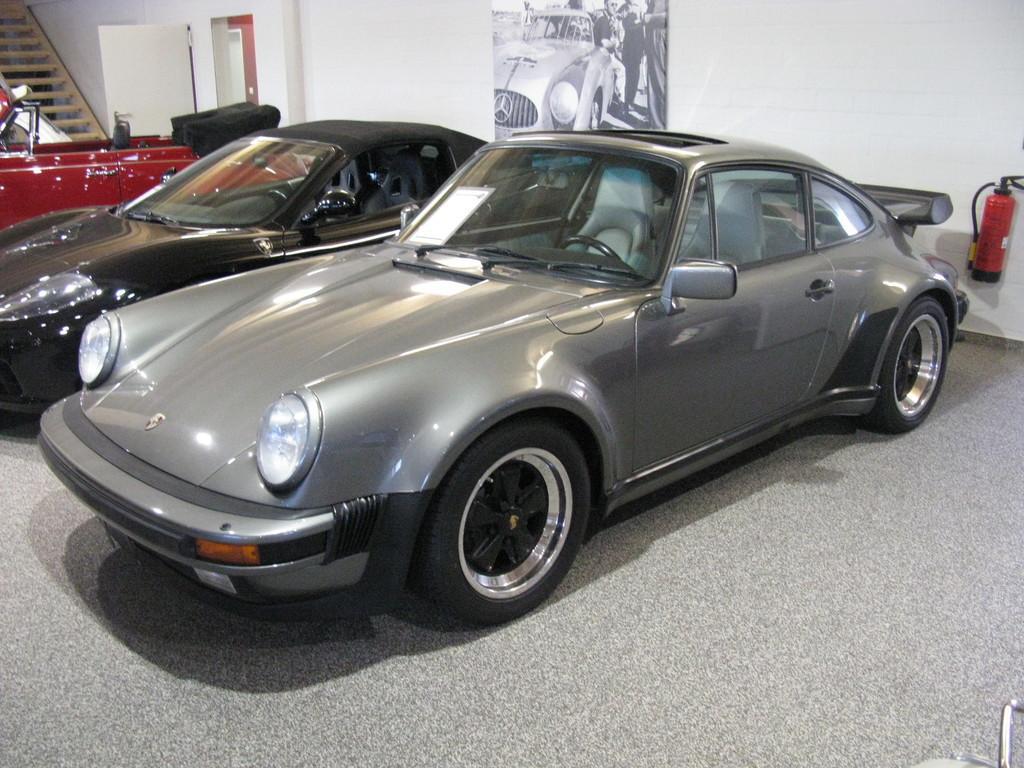Can you describe this image briefly? In this picture we can see cars on the floor, fire extinguisher, door, steps and in the background we can see a poster on the wall. 